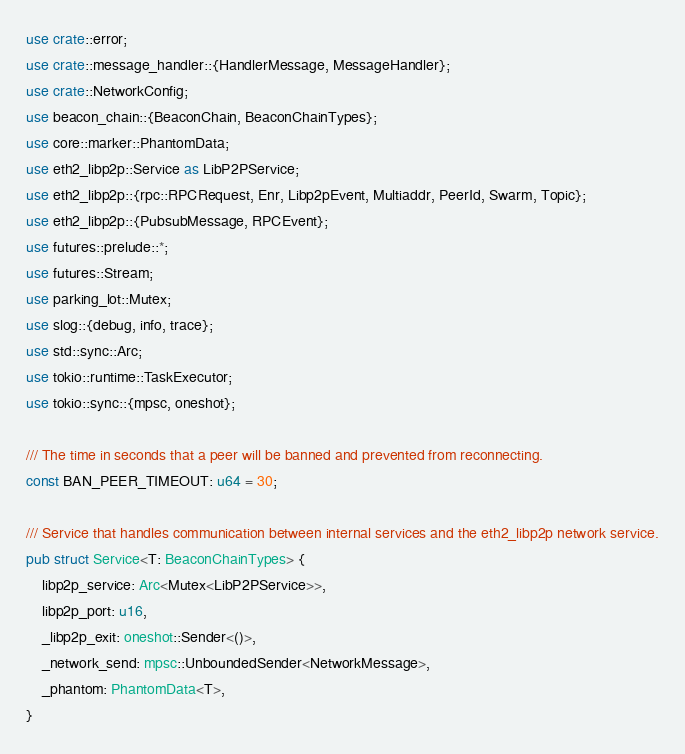<code> <loc_0><loc_0><loc_500><loc_500><_Rust_>use crate::error;
use crate::message_handler::{HandlerMessage, MessageHandler};
use crate::NetworkConfig;
use beacon_chain::{BeaconChain, BeaconChainTypes};
use core::marker::PhantomData;
use eth2_libp2p::Service as LibP2PService;
use eth2_libp2p::{rpc::RPCRequest, Enr, Libp2pEvent, Multiaddr, PeerId, Swarm, Topic};
use eth2_libp2p::{PubsubMessage, RPCEvent};
use futures::prelude::*;
use futures::Stream;
use parking_lot::Mutex;
use slog::{debug, info, trace};
use std::sync::Arc;
use tokio::runtime::TaskExecutor;
use tokio::sync::{mpsc, oneshot};

/// The time in seconds that a peer will be banned and prevented from reconnecting.
const BAN_PEER_TIMEOUT: u64 = 30;

/// Service that handles communication between internal services and the eth2_libp2p network service.
pub struct Service<T: BeaconChainTypes> {
    libp2p_service: Arc<Mutex<LibP2PService>>,
    libp2p_port: u16,
    _libp2p_exit: oneshot::Sender<()>,
    _network_send: mpsc::UnboundedSender<NetworkMessage>,
    _phantom: PhantomData<T>,
}
</code> 